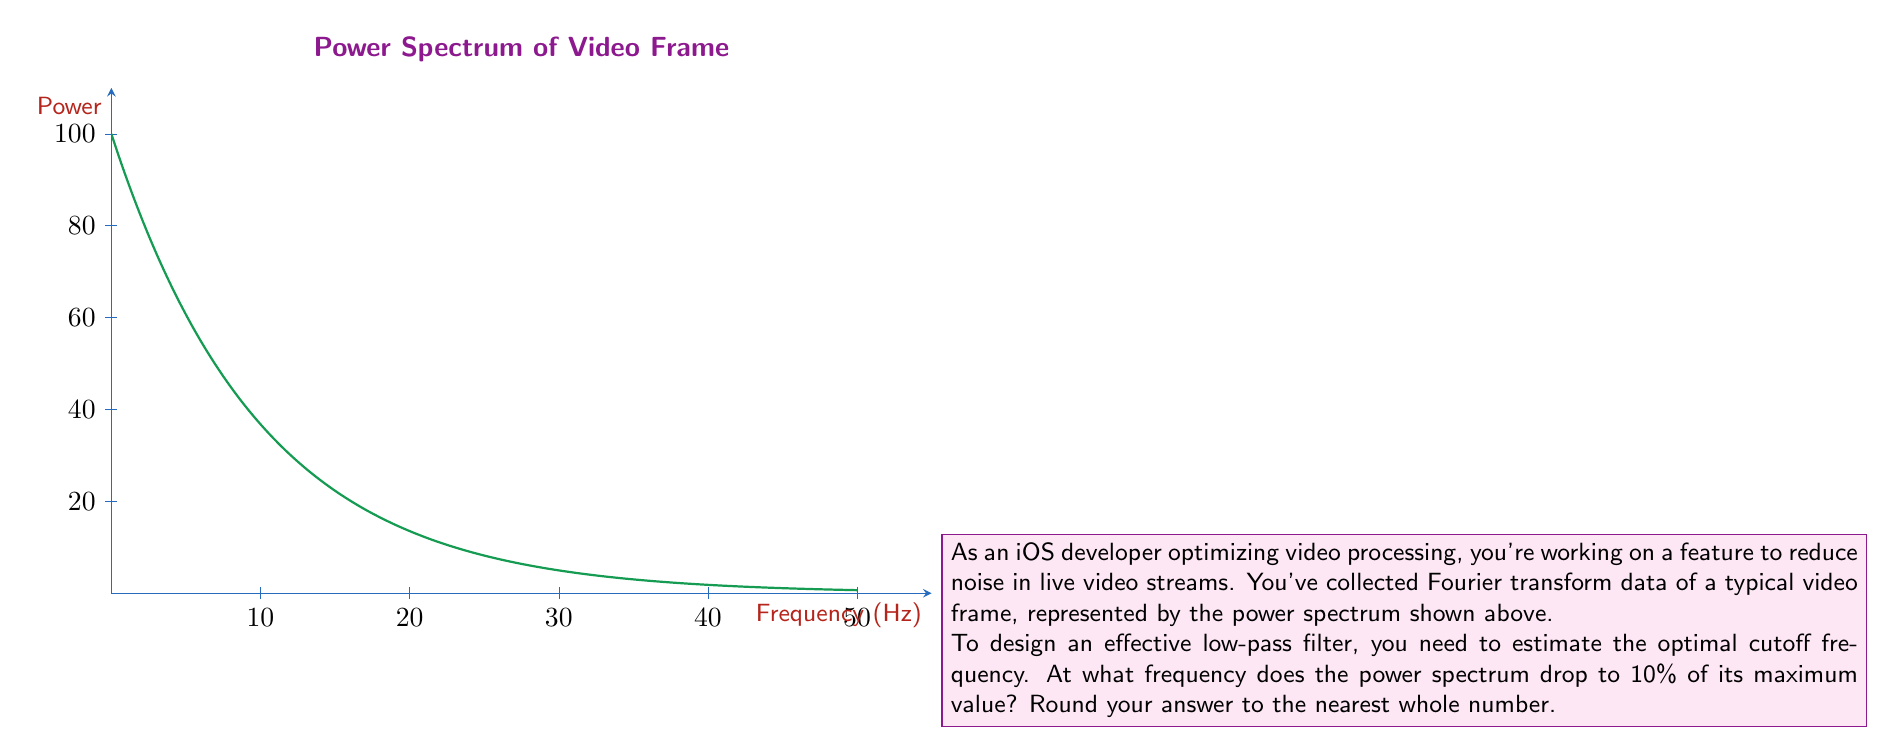Can you solve this math problem? Let's approach this step-by-step:

1) The power spectrum is given by the function:
   $$P(f) = 100e^{-f/10}$$
   where $f$ is the frequency in Hz.

2) The maximum value occurs at $f=0$:
   $$P(0) = 100e^0 = 100$$

3) We need to find $f$ where $P(f)$ is 10% of the maximum:
   $$P(f) = 0.1 \cdot 100 = 10$$

4) Set up the equation:
   $$10 = 100e^{-f/10}$$

5) Divide both sides by 100:
   $$0.1 = e^{-f/10}$$

6) Take the natural log of both sides:
   $$\ln(0.1) = -f/10$$

7) Multiply both sides by -10:
   $$-10\ln(0.1) = f$$

8) Calculate:
   $$f = -10\ln(0.1) \approx 23.03$$

9) Rounding to the nearest whole number:
   $$f \approx 23\text{ Hz}$$

Therefore, the optimal cutoff frequency for the low-pass filter is approximately 23 Hz.
Answer: 23 Hz 